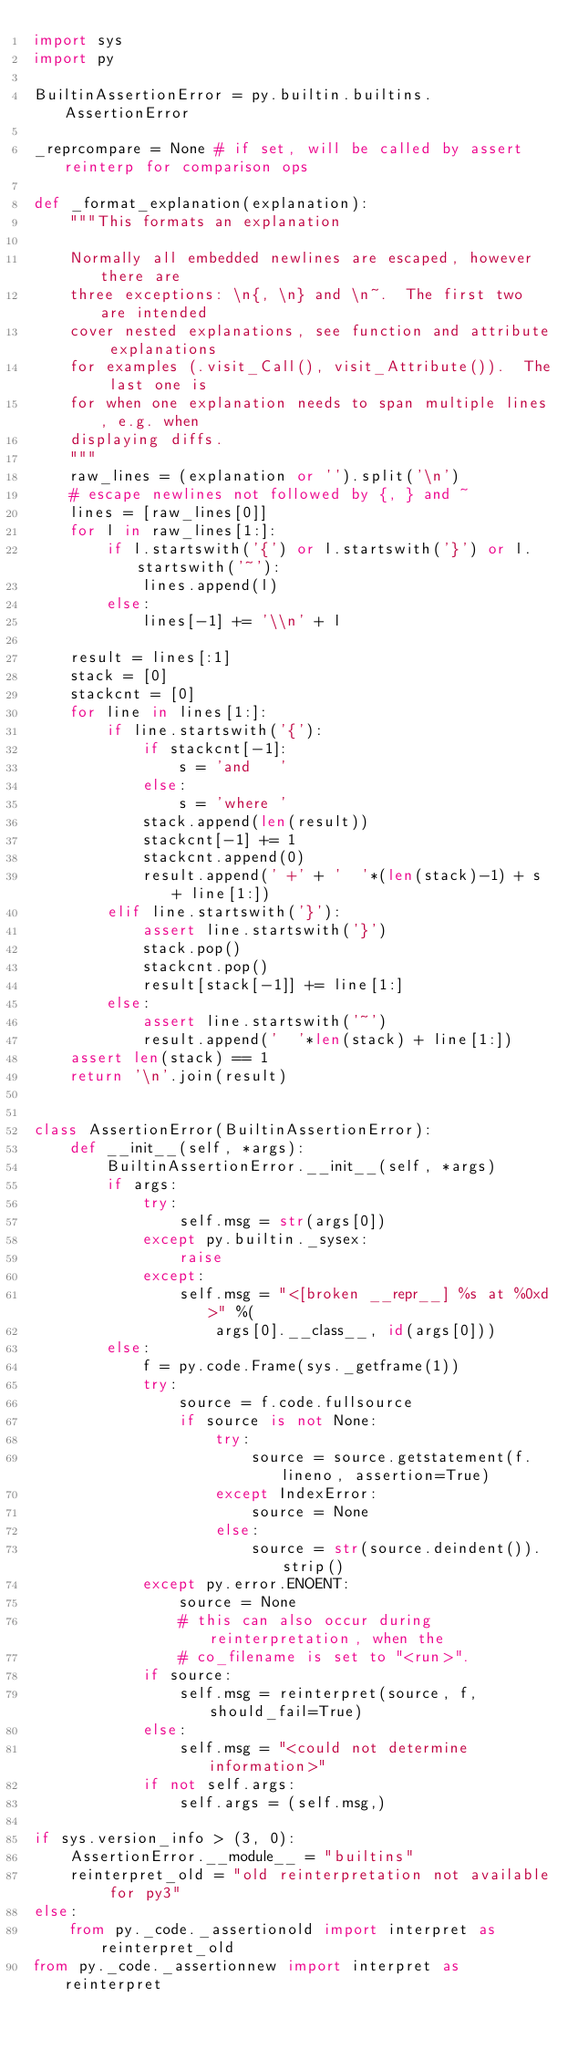Convert code to text. <code><loc_0><loc_0><loc_500><loc_500><_Python_>import sys
import py

BuiltinAssertionError = py.builtin.builtins.AssertionError

_reprcompare = None # if set, will be called by assert reinterp for comparison ops

def _format_explanation(explanation):
    """This formats an explanation

    Normally all embedded newlines are escaped, however there are
    three exceptions: \n{, \n} and \n~.  The first two are intended
    cover nested explanations, see function and attribute explanations
    for examples (.visit_Call(), visit_Attribute()).  The last one is
    for when one explanation needs to span multiple lines, e.g. when
    displaying diffs.
    """
    raw_lines = (explanation or '').split('\n')
    # escape newlines not followed by {, } and ~
    lines = [raw_lines[0]]
    for l in raw_lines[1:]:
        if l.startswith('{') or l.startswith('}') or l.startswith('~'):
            lines.append(l)
        else:
            lines[-1] += '\\n' + l

    result = lines[:1]
    stack = [0]
    stackcnt = [0]
    for line in lines[1:]:
        if line.startswith('{'):
            if stackcnt[-1]:
                s = 'and   '
            else:
                s = 'where '
            stack.append(len(result))
            stackcnt[-1] += 1
            stackcnt.append(0)
            result.append(' +' + '  '*(len(stack)-1) + s + line[1:])
        elif line.startswith('}'):
            assert line.startswith('}')
            stack.pop()
            stackcnt.pop()
            result[stack[-1]] += line[1:]
        else:
            assert line.startswith('~')
            result.append('  '*len(stack) + line[1:])
    assert len(stack) == 1
    return '\n'.join(result)


class AssertionError(BuiltinAssertionError):
    def __init__(self, *args):
        BuiltinAssertionError.__init__(self, *args)
        if args:
            try:
                self.msg = str(args[0])
            except py.builtin._sysex:
                raise
            except:
                self.msg = "<[broken __repr__] %s at %0xd>" %(
                    args[0].__class__, id(args[0]))
        else:
            f = py.code.Frame(sys._getframe(1))
            try:
                source = f.code.fullsource
                if source is not None:
                    try:
                        source = source.getstatement(f.lineno, assertion=True)
                    except IndexError:
                        source = None
                    else:
                        source = str(source.deindent()).strip()
            except py.error.ENOENT:
                source = None
                # this can also occur during reinterpretation, when the
                # co_filename is set to "<run>".
            if source:
                self.msg = reinterpret(source, f, should_fail=True)
            else:
                self.msg = "<could not determine information>"
            if not self.args:
                self.args = (self.msg,)

if sys.version_info > (3, 0):
    AssertionError.__module__ = "builtins"
    reinterpret_old = "old reinterpretation not available for py3"
else:
    from py._code._assertionold import interpret as reinterpret_old
from py._code._assertionnew import interpret as reinterpret
</code> 